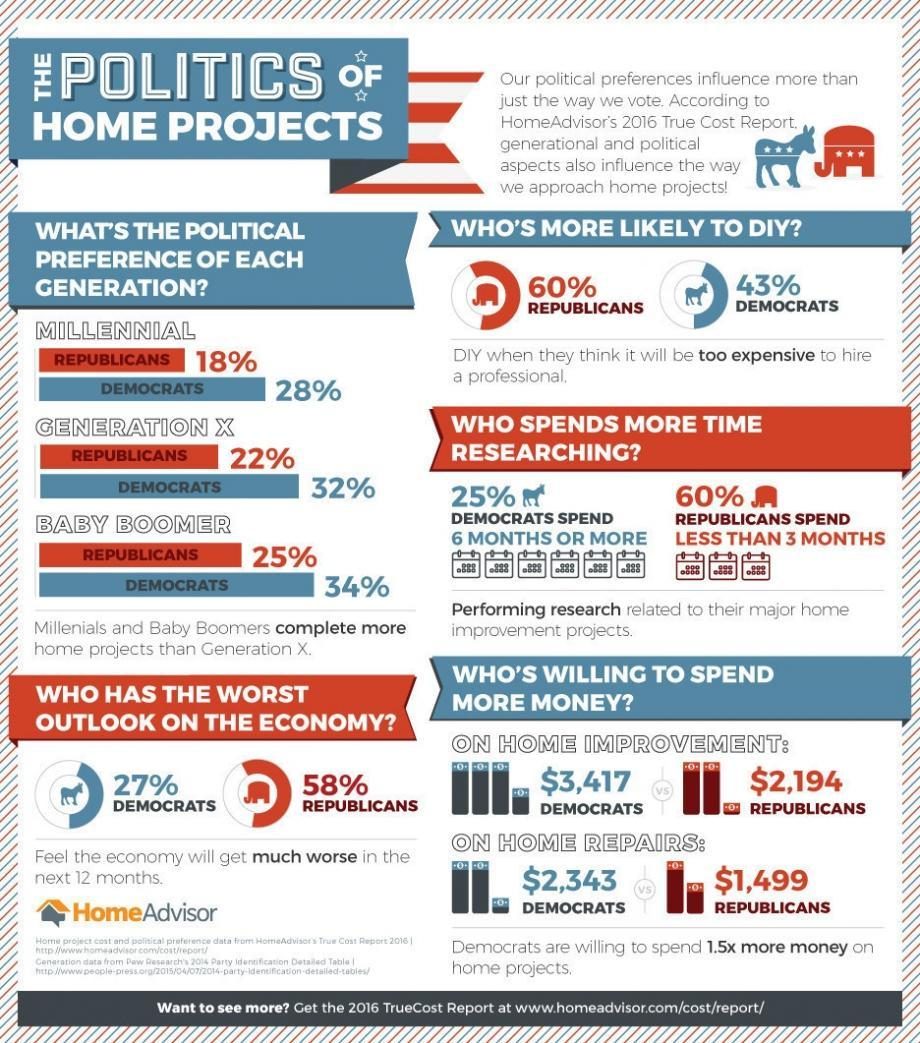Mention a couple of crucial points in this snapshot. According to recent polls, the majority of millennials prefer the Democratic Party over the Republican Party. According to available data, the total amount of money that Republican voters are willing to pay for home repairs and home improvement taken together is $3,693. The majority of baby boomers prefer the Democratic Party among both Democrats and Republicans. Generation X prefers the Democratic Party over the Republican Party. Democrats are more likely to spend more money on home repairs than Republicans," said the source. 